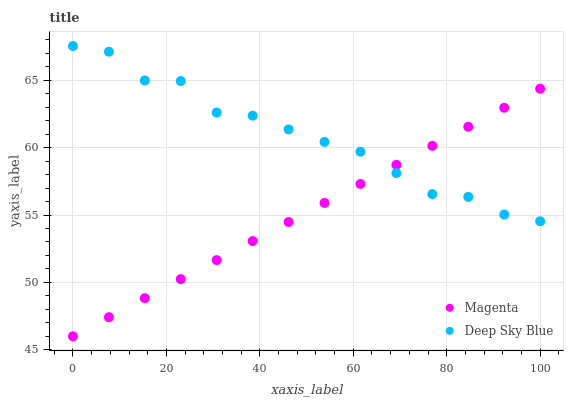Does Magenta have the minimum area under the curve?
Answer yes or no. Yes. Does Deep Sky Blue have the maximum area under the curve?
Answer yes or no. Yes. Does Deep Sky Blue have the minimum area under the curve?
Answer yes or no. No. Is Magenta the smoothest?
Answer yes or no. Yes. Is Deep Sky Blue the roughest?
Answer yes or no. Yes. Is Deep Sky Blue the smoothest?
Answer yes or no. No. Does Magenta have the lowest value?
Answer yes or no. Yes. Does Deep Sky Blue have the lowest value?
Answer yes or no. No. Does Deep Sky Blue have the highest value?
Answer yes or no. Yes. Does Deep Sky Blue intersect Magenta?
Answer yes or no. Yes. Is Deep Sky Blue less than Magenta?
Answer yes or no. No. Is Deep Sky Blue greater than Magenta?
Answer yes or no. No. 